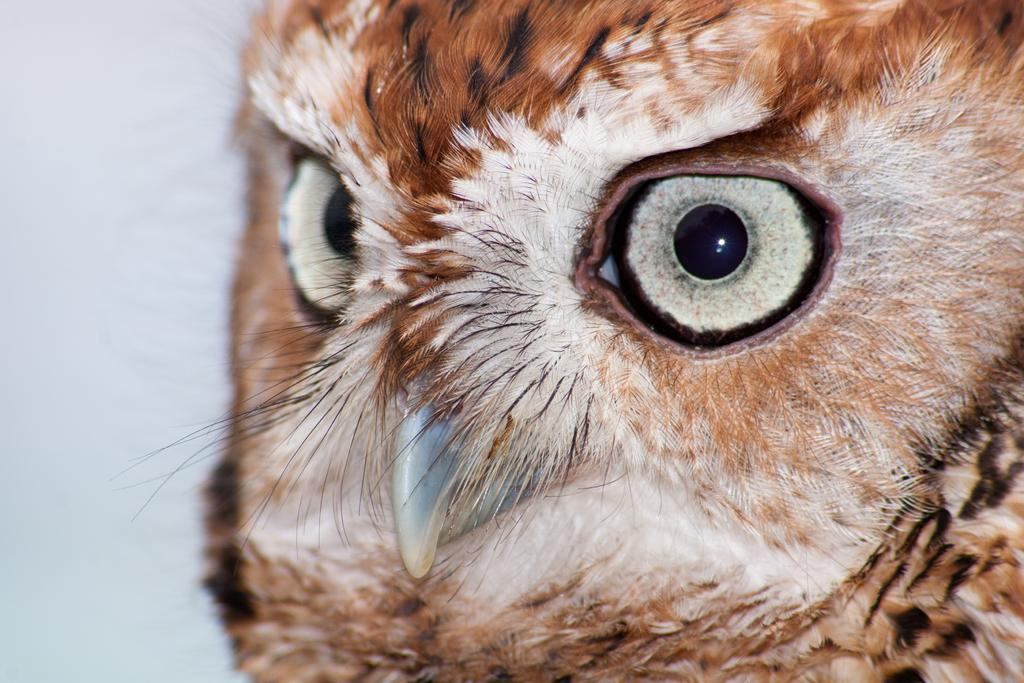What is the main subject of the image? The main subject of the image is a bird's face. Can you describe the background of the image? The background of the image is blurred. How many clovers can be seen growing in the background of the image? There are no clovers visible in the image, as the background is blurred and does not show any plants or vegetation. 